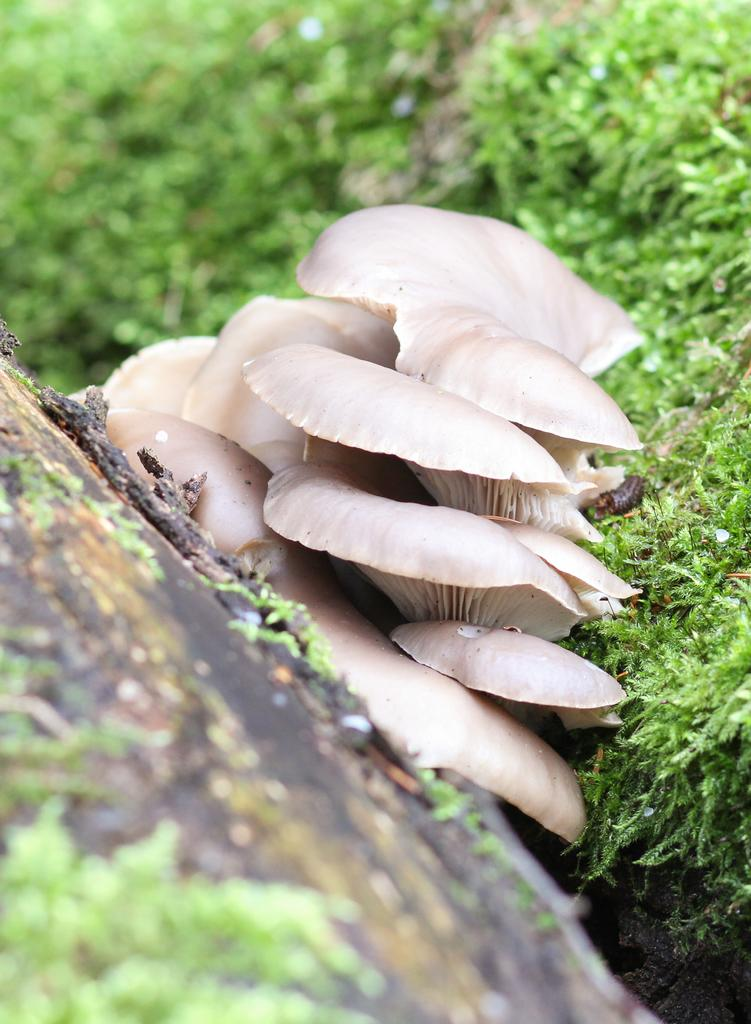What type of mushroom is in the image? There is an oyster mushroom in the image. Where is the mushroom located in relation to the grass? The mushroom is beside the grass. How is the background of the mushroom depicted in the image? The background of the mushroom is blurred. What type of paste is being used to hold the book open in the image? There is no paste or book present in the image; it only features an oyster mushroom beside the grass. 